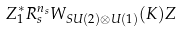Convert formula to latex. <formula><loc_0><loc_0><loc_500><loc_500>Z _ { 1 } ^ { * } R _ { s } ^ { n _ { s } } W _ { S U ( 2 ) \otimes U ( 1 ) } ( K ) Z</formula> 